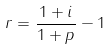<formula> <loc_0><loc_0><loc_500><loc_500>r = \frac { 1 + i } { 1 + p } - 1</formula> 